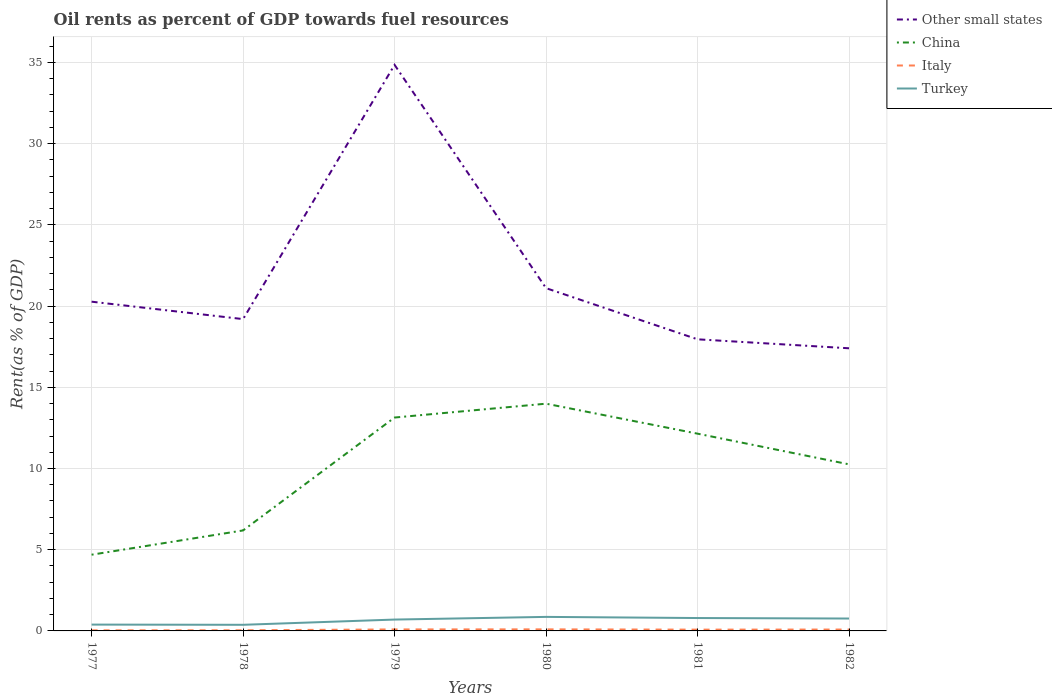Does the line corresponding to Other small states intersect with the line corresponding to Italy?
Offer a terse response. No. Is the number of lines equal to the number of legend labels?
Your answer should be very brief. Yes. Across all years, what is the maximum oil rent in Other small states?
Your response must be concise. 17.4. In which year was the oil rent in Italy maximum?
Your answer should be compact. 1977. What is the total oil rent in Other small states in the graph?
Provide a short and direct response. 3.7. What is the difference between the highest and the second highest oil rent in Other small states?
Your response must be concise. 17.45. What is the difference between the highest and the lowest oil rent in China?
Offer a very short reply. 4. Are the values on the major ticks of Y-axis written in scientific E-notation?
Offer a very short reply. No. Does the graph contain grids?
Ensure brevity in your answer.  Yes. How are the legend labels stacked?
Offer a terse response. Vertical. What is the title of the graph?
Make the answer very short. Oil rents as percent of GDP towards fuel resources. What is the label or title of the Y-axis?
Make the answer very short. Rent(as % of GDP). What is the Rent(as % of GDP) in Other small states in 1977?
Offer a very short reply. 20.27. What is the Rent(as % of GDP) in China in 1977?
Your answer should be compact. 4.69. What is the Rent(as % of GDP) of Italy in 1977?
Your response must be concise. 0.04. What is the Rent(as % of GDP) of Turkey in 1977?
Provide a succinct answer. 0.39. What is the Rent(as % of GDP) of Other small states in 1978?
Your answer should be very brief. 19.2. What is the Rent(as % of GDP) of China in 1978?
Keep it short and to the point. 6.19. What is the Rent(as % of GDP) of Italy in 1978?
Ensure brevity in your answer.  0.04. What is the Rent(as % of GDP) in Turkey in 1978?
Provide a short and direct response. 0.38. What is the Rent(as % of GDP) in Other small states in 1979?
Offer a very short reply. 34.86. What is the Rent(as % of GDP) in China in 1979?
Give a very brief answer. 13.14. What is the Rent(as % of GDP) in Italy in 1979?
Offer a very short reply. 0.09. What is the Rent(as % of GDP) of Turkey in 1979?
Provide a short and direct response. 0.7. What is the Rent(as % of GDP) of Other small states in 1980?
Offer a terse response. 21.1. What is the Rent(as % of GDP) in China in 1980?
Give a very brief answer. 13.99. What is the Rent(as % of GDP) of Italy in 1980?
Your answer should be compact. 0.1. What is the Rent(as % of GDP) of Turkey in 1980?
Offer a very short reply. 0.86. What is the Rent(as % of GDP) in Other small states in 1981?
Your response must be concise. 17.96. What is the Rent(as % of GDP) in China in 1981?
Offer a very short reply. 12.15. What is the Rent(as % of GDP) of Italy in 1981?
Offer a very short reply. 0.08. What is the Rent(as % of GDP) of Turkey in 1981?
Offer a terse response. 0.79. What is the Rent(as % of GDP) in Other small states in 1982?
Ensure brevity in your answer.  17.4. What is the Rent(as % of GDP) of China in 1982?
Offer a very short reply. 10.26. What is the Rent(as % of GDP) of Italy in 1982?
Provide a succinct answer. 0.09. What is the Rent(as % of GDP) in Turkey in 1982?
Offer a terse response. 0.76. Across all years, what is the maximum Rent(as % of GDP) of Other small states?
Ensure brevity in your answer.  34.86. Across all years, what is the maximum Rent(as % of GDP) in China?
Your answer should be very brief. 13.99. Across all years, what is the maximum Rent(as % of GDP) in Italy?
Give a very brief answer. 0.1. Across all years, what is the maximum Rent(as % of GDP) in Turkey?
Provide a short and direct response. 0.86. Across all years, what is the minimum Rent(as % of GDP) of Other small states?
Provide a short and direct response. 17.4. Across all years, what is the minimum Rent(as % of GDP) in China?
Your answer should be very brief. 4.69. Across all years, what is the minimum Rent(as % of GDP) in Italy?
Your response must be concise. 0.04. Across all years, what is the minimum Rent(as % of GDP) of Turkey?
Offer a very short reply. 0.38. What is the total Rent(as % of GDP) in Other small states in the graph?
Offer a terse response. 130.79. What is the total Rent(as % of GDP) in China in the graph?
Make the answer very short. 60.41. What is the total Rent(as % of GDP) of Italy in the graph?
Your response must be concise. 0.43. What is the total Rent(as % of GDP) of Turkey in the graph?
Your response must be concise. 3.89. What is the difference between the Rent(as % of GDP) in Other small states in 1977 and that in 1978?
Provide a succinct answer. 1.07. What is the difference between the Rent(as % of GDP) in China in 1977 and that in 1978?
Offer a terse response. -1.49. What is the difference between the Rent(as % of GDP) of Italy in 1977 and that in 1978?
Your answer should be very brief. -0. What is the difference between the Rent(as % of GDP) in Turkey in 1977 and that in 1978?
Provide a succinct answer. 0.01. What is the difference between the Rent(as % of GDP) of Other small states in 1977 and that in 1979?
Give a very brief answer. -14.58. What is the difference between the Rent(as % of GDP) in China in 1977 and that in 1979?
Your answer should be very brief. -8.45. What is the difference between the Rent(as % of GDP) of Italy in 1977 and that in 1979?
Give a very brief answer. -0.06. What is the difference between the Rent(as % of GDP) of Turkey in 1977 and that in 1979?
Ensure brevity in your answer.  -0.31. What is the difference between the Rent(as % of GDP) in Other small states in 1977 and that in 1980?
Offer a very short reply. -0.83. What is the difference between the Rent(as % of GDP) of China in 1977 and that in 1980?
Provide a short and direct response. -9.3. What is the difference between the Rent(as % of GDP) in Italy in 1977 and that in 1980?
Provide a short and direct response. -0.06. What is the difference between the Rent(as % of GDP) of Turkey in 1977 and that in 1980?
Give a very brief answer. -0.47. What is the difference between the Rent(as % of GDP) of Other small states in 1977 and that in 1981?
Ensure brevity in your answer.  2.32. What is the difference between the Rent(as % of GDP) of China in 1977 and that in 1981?
Provide a short and direct response. -7.45. What is the difference between the Rent(as % of GDP) in Italy in 1977 and that in 1981?
Ensure brevity in your answer.  -0.04. What is the difference between the Rent(as % of GDP) in Turkey in 1977 and that in 1981?
Provide a succinct answer. -0.4. What is the difference between the Rent(as % of GDP) in Other small states in 1977 and that in 1982?
Offer a terse response. 2.87. What is the difference between the Rent(as % of GDP) in China in 1977 and that in 1982?
Give a very brief answer. -5.56. What is the difference between the Rent(as % of GDP) of Italy in 1977 and that in 1982?
Your response must be concise. -0.05. What is the difference between the Rent(as % of GDP) of Turkey in 1977 and that in 1982?
Make the answer very short. -0.37. What is the difference between the Rent(as % of GDP) in Other small states in 1978 and that in 1979?
Make the answer very short. -15.66. What is the difference between the Rent(as % of GDP) of China in 1978 and that in 1979?
Make the answer very short. -6.95. What is the difference between the Rent(as % of GDP) of Italy in 1978 and that in 1979?
Give a very brief answer. -0.05. What is the difference between the Rent(as % of GDP) of Turkey in 1978 and that in 1979?
Provide a succinct answer. -0.32. What is the difference between the Rent(as % of GDP) in Other small states in 1978 and that in 1980?
Offer a terse response. -1.91. What is the difference between the Rent(as % of GDP) in China in 1978 and that in 1980?
Ensure brevity in your answer.  -7.8. What is the difference between the Rent(as % of GDP) of Italy in 1978 and that in 1980?
Offer a terse response. -0.06. What is the difference between the Rent(as % of GDP) in Turkey in 1978 and that in 1980?
Your response must be concise. -0.49. What is the difference between the Rent(as % of GDP) in Other small states in 1978 and that in 1981?
Your response must be concise. 1.24. What is the difference between the Rent(as % of GDP) of China in 1978 and that in 1981?
Offer a very short reply. -5.96. What is the difference between the Rent(as % of GDP) of Italy in 1978 and that in 1981?
Provide a short and direct response. -0.04. What is the difference between the Rent(as % of GDP) of Turkey in 1978 and that in 1981?
Offer a very short reply. -0.42. What is the difference between the Rent(as % of GDP) in Other small states in 1978 and that in 1982?
Offer a terse response. 1.8. What is the difference between the Rent(as % of GDP) of China in 1978 and that in 1982?
Offer a very short reply. -4.07. What is the difference between the Rent(as % of GDP) in Italy in 1978 and that in 1982?
Your answer should be very brief. -0.04. What is the difference between the Rent(as % of GDP) in Turkey in 1978 and that in 1982?
Give a very brief answer. -0.39. What is the difference between the Rent(as % of GDP) of Other small states in 1979 and that in 1980?
Keep it short and to the point. 13.75. What is the difference between the Rent(as % of GDP) in China in 1979 and that in 1980?
Your answer should be very brief. -0.85. What is the difference between the Rent(as % of GDP) in Italy in 1979 and that in 1980?
Keep it short and to the point. -0. What is the difference between the Rent(as % of GDP) of Turkey in 1979 and that in 1980?
Provide a short and direct response. -0.16. What is the difference between the Rent(as % of GDP) in Other small states in 1979 and that in 1981?
Provide a succinct answer. 16.9. What is the difference between the Rent(as % of GDP) of Italy in 1979 and that in 1981?
Offer a very short reply. 0.01. What is the difference between the Rent(as % of GDP) in Turkey in 1979 and that in 1981?
Keep it short and to the point. -0.09. What is the difference between the Rent(as % of GDP) in Other small states in 1979 and that in 1982?
Keep it short and to the point. 17.45. What is the difference between the Rent(as % of GDP) of China in 1979 and that in 1982?
Give a very brief answer. 2.88. What is the difference between the Rent(as % of GDP) of Italy in 1979 and that in 1982?
Your answer should be very brief. 0.01. What is the difference between the Rent(as % of GDP) of Turkey in 1979 and that in 1982?
Ensure brevity in your answer.  -0.06. What is the difference between the Rent(as % of GDP) of Other small states in 1980 and that in 1981?
Provide a succinct answer. 3.15. What is the difference between the Rent(as % of GDP) of China in 1980 and that in 1981?
Ensure brevity in your answer.  1.85. What is the difference between the Rent(as % of GDP) of Italy in 1980 and that in 1981?
Ensure brevity in your answer.  0.02. What is the difference between the Rent(as % of GDP) of Turkey in 1980 and that in 1981?
Your answer should be very brief. 0.07. What is the difference between the Rent(as % of GDP) in Other small states in 1980 and that in 1982?
Keep it short and to the point. 3.7. What is the difference between the Rent(as % of GDP) of China in 1980 and that in 1982?
Make the answer very short. 3.73. What is the difference between the Rent(as % of GDP) of Italy in 1980 and that in 1982?
Make the answer very short. 0.01. What is the difference between the Rent(as % of GDP) of Turkey in 1980 and that in 1982?
Make the answer very short. 0.1. What is the difference between the Rent(as % of GDP) in Other small states in 1981 and that in 1982?
Your answer should be very brief. 0.55. What is the difference between the Rent(as % of GDP) of China in 1981 and that in 1982?
Keep it short and to the point. 1.89. What is the difference between the Rent(as % of GDP) of Italy in 1981 and that in 1982?
Give a very brief answer. -0.01. What is the difference between the Rent(as % of GDP) in Turkey in 1981 and that in 1982?
Your response must be concise. 0.03. What is the difference between the Rent(as % of GDP) in Other small states in 1977 and the Rent(as % of GDP) in China in 1978?
Ensure brevity in your answer.  14.09. What is the difference between the Rent(as % of GDP) of Other small states in 1977 and the Rent(as % of GDP) of Italy in 1978?
Ensure brevity in your answer.  20.23. What is the difference between the Rent(as % of GDP) of Other small states in 1977 and the Rent(as % of GDP) of Turkey in 1978?
Make the answer very short. 19.9. What is the difference between the Rent(as % of GDP) of China in 1977 and the Rent(as % of GDP) of Italy in 1978?
Your answer should be very brief. 4.65. What is the difference between the Rent(as % of GDP) of China in 1977 and the Rent(as % of GDP) of Turkey in 1978?
Your answer should be very brief. 4.32. What is the difference between the Rent(as % of GDP) of Italy in 1977 and the Rent(as % of GDP) of Turkey in 1978?
Keep it short and to the point. -0.34. What is the difference between the Rent(as % of GDP) in Other small states in 1977 and the Rent(as % of GDP) in China in 1979?
Your answer should be compact. 7.13. What is the difference between the Rent(as % of GDP) in Other small states in 1977 and the Rent(as % of GDP) in Italy in 1979?
Offer a terse response. 20.18. What is the difference between the Rent(as % of GDP) in Other small states in 1977 and the Rent(as % of GDP) in Turkey in 1979?
Provide a succinct answer. 19.57. What is the difference between the Rent(as % of GDP) of China in 1977 and the Rent(as % of GDP) of Italy in 1979?
Keep it short and to the point. 4.6. What is the difference between the Rent(as % of GDP) in China in 1977 and the Rent(as % of GDP) in Turkey in 1979?
Keep it short and to the point. 3.99. What is the difference between the Rent(as % of GDP) in Italy in 1977 and the Rent(as % of GDP) in Turkey in 1979?
Provide a succinct answer. -0.66. What is the difference between the Rent(as % of GDP) of Other small states in 1977 and the Rent(as % of GDP) of China in 1980?
Give a very brief answer. 6.28. What is the difference between the Rent(as % of GDP) in Other small states in 1977 and the Rent(as % of GDP) in Italy in 1980?
Provide a succinct answer. 20.18. What is the difference between the Rent(as % of GDP) of Other small states in 1977 and the Rent(as % of GDP) of Turkey in 1980?
Your answer should be compact. 19.41. What is the difference between the Rent(as % of GDP) in China in 1977 and the Rent(as % of GDP) in Italy in 1980?
Give a very brief answer. 4.6. What is the difference between the Rent(as % of GDP) of China in 1977 and the Rent(as % of GDP) of Turkey in 1980?
Provide a succinct answer. 3.83. What is the difference between the Rent(as % of GDP) of Italy in 1977 and the Rent(as % of GDP) of Turkey in 1980?
Provide a short and direct response. -0.83. What is the difference between the Rent(as % of GDP) of Other small states in 1977 and the Rent(as % of GDP) of China in 1981?
Your response must be concise. 8.13. What is the difference between the Rent(as % of GDP) of Other small states in 1977 and the Rent(as % of GDP) of Italy in 1981?
Your response must be concise. 20.19. What is the difference between the Rent(as % of GDP) in Other small states in 1977 and the Rent(as % of GDP) in Turkey in 1981?
Provide a succinct answer. 19.48. What is the difference between the Rent(as % of GDP) of China in 1977 and the Rent(as % of GDP) of Italy in 1981?
Provide a short and direct response. 4.61. What is the difference between the Rent(as % of GDP) in China in 1977 and the Rent(as % of GDP) in Turkey in 1981?
Keep it short and to the point. 3.9. What is the difference between the Rent(as % of GDP) in Italy in 1977 and the Rent(as % of GDP) in Turkey in 1981?
Give a very brief answer. -0.76. What is the difference between the Rent(as % of GDP) of Other small states in 1977 and the Rent(as % of GDP) of China in 1982?
Offer a very short reply. 10.02. What is the difference between the Rent(as % of GDP) in Other small states in 1977 and the Rent(as % of GDP) in Italy in 1982?
Provide a short and direct response. 20.19. What is the difference between the Rent(as % of GDP) in Other small states in 1977 and the Rent(as % of GDP) in Turkey in 1982?
Your answer should be compact. 19.51. What is the difference between the Rent(as % of GDP) of China in 1977 and the Rent(as % of GDP) of Italy in 1982?
Your response must be concise. 4.61. What is the difference between the Rent(as % of GDP) of China in 1977 and the Rent(as % of GDP) of Turkey in 1982?
Provide a succinct answer. 3.93. What is the difference between the Rent(as % of GDP) of Italy in 1977 and the Rent(as % of GDP) of Turkey in 1982?
Your response must be concise. -0.73. What is the difference between the Rent(as % of GDP) in Other small states in 1978 and the Rent(as % of GDP) in China in 1979?
Your answer should be compact. 6.06. What is the difference between the Rent(as % of GDP) of Other small states in 1978 and the Rent(as % of GDP) of Italy in 1979?
Ensure brevity in your answer.  19.11. What is the difference between the Rent(as % of GDP) in Other small states in 1978 and the Rent(as % of GDP) in Turkey in 1979?
Keep it short and to the point. 18.5. What is the difference between the Rent(as % of GDP) in China in 1978 and the Rent(as % of GDP) in Italy in 1979?
Offer a terse response. 6.09. What is the difference between the Rent(as % of GDP) of China in 1978 and the Rent(as % of GDP) of Turkey in 1979?
Provide a succinct answer. 5.49. What is the difference between the Rent(as % of GDP) in Italy in 1978 and the Rent(as % of GDP) in Turkey in 1979?
Offer a terse response. -0.66. What is the difference between the Rent(as % of GDP) in Other small states in 1978 and the Rent(as % of GDP) in China in 1980?
Provide a short and direct response. 5.21. What is the difference between the Rent(as % of GDP) of Other small states in 1978 and the Rent(as % of GDP) of Italy in 1980?
Give a very brief answer. 19.1. What is the difference between the Rent(as % of GDP) of Other small states in 1978 and the Rent(as % of GDP) of Turkey in 1980?
Offer a very short reply. 18.34. What is the difference between the Rent(as % of GDP) of China in 1978 and the Rent(as % of GDP) of Italy in 1980?
Ensure brevity in your answer.  6.09. What is the difference between the Rent(as % of GDP) of China in 1978 and the Rent(as % of GDP) of Turkey in 1980?
Your answer should be very brief. 5.32. What is the difference between the Rent(as % of GDP) in Italy in 1978 and the Rent(as % of GDP) in Turkey in 1980?
Offer a terse response. -0.82. What is the difference between the Rent(as % of GDP) in Other small states in 1978 and the Rent(as % of GDP) in China in 1981?
Give a very brief answer. 7.05. What is the difference between the Rent(as % of GDP) of Other small states in 1978 and the Rent(as % of GDP) of Italy in 1981?
Ensure brevity in your answer.  19.12. What is the difference between the Rent(as % of GDP) of Other small states in 1978 and the Rent(as % of GDP) of Turkey in 1981?
Offer a very short reply. 18.41. What is the difference between the Rent(as % of GDP) of China in 1978 and the Rent(as % of GDP) of Italy in 1981?
Your response must be concise. 6.11. What is the difference between the Rent(as % of GDP) in China in 1978 and the Rent(as % of GDP) in Turkey in 1981?
Ensure brevity in your answer.  5.39. What is the difference between the Rent(as % of GDP) of Italy in 1978 and the Rent(as % of GDP) of Turkey in 1981?
Provide a succinct answer. -0.75. What is the difference between the Rent(as % of GDP) in Other small states in 1978 and the Rent(as % of GDP) in China in 1982?
Your answer should be very brief. 8.94. What is the difference between the Rent(as % of GDP) in Other small states in 1978 and the Rent(as % of GDP) in Italy in 1982?
Your response must be concise. 19.11. What is the difference between the Rent(as % of GDP) in Other small states in 1978 and the Rent(as % of GDP) in Turkey in 1982?
Your answer should be very brief. 18.44. What is the difference between the Rent(as % of GDP) of China in 1978 and the Rent(as % of GDP) of Italy in 1982?
Provide a succinct answer. 6.1. What is the difference between the Rent(as % of GDP) in China in 1978 and the Rent(as % of GDP) in Turkey in 1982?
Give a very brief answer. 5.42. What is the difference between the Rent(as % of GDP) in Italy in 1978 and the Rent(as % of GDP) in Turkey in 1982?
Make the answer very short. -0.72. What is the difference between the Rent(as % of GDP) in Other small states in 1979 and the Rent(as % of GDP) in China in 1980?
Offer a terse response. 20.86. What is the difference between the Rent(as % of GDP) in Other small states in 1979 and the Rent(as % of GDP) in Italy in 1980?
Keep it short and to the point. 34.76. What is the difference between the Rent(as % of GDP) of Other small states in 1979 and the Rent(as % of GDP) of Turkey in 1980?
Your response must be concise. 33.99. What is the difference between the Rent(as % of GDP) in China in 1979 and the Rent(as % of GDP) in Italy in 1980?
Offer a terse response. 13.04. What is the difference between the Rent(as % of GDP) of China in 1979 and the Rent(as % of GDP) of Turkey in 1980?
Your answer should be compact. 12.27. What is the difference between the Rent(as % of GDP) of Italy in 1979 and the Rent(as % of GDP) of Turkey in 1980?
Give a very brief answer. -0.77. What is the difference between the Rent(as % of GDP) of Other small states in 1979 and the Rent(as % of GDP) of China in 1981?
Your answer should be compact. 22.71. What is the difference between the Rent(as % of GDP) in Other small states in 1979 and the Rent(as % of GDP) in Italy in 1981?
Offer a very short reply. 34.78. What is the difference between the Rent(as % of GDP) in Other small states in 1979 and the Rent(as % of GDP) in Turkey in 1981?
Provide a short and direct response. 34.06. What is the difference between the Rent(as % of GDP) in China in 1979 and the Rent(as % of GDP) in Italy in 1981?
Your answer should be compact. 13.06. What is the difference between the Rent(as % of GDP) in China in 1979 and the Rent(as % of GDP) in Turkey in 1981?
Provide a succinct answer. 12.34. What is the difference between the Rent(as % of GDP) of Italy in 1979 and the Rent(as % of GDP) of Turkey in 1981?
Provide a short and direct response. -0.7. What is the difference between the Rent(as % of GDP) of Other small states in 1979 and the Rent(as % of GDP) of China in 1982?
Your answer should be very brief. 24.6. What is the difference between the Rent(as % of GDP) in Other small states in 1979 and the Rent(as % of GDP) in Italy in 1982?
Offer a terse response. 34.77. What is the difference between the Rent(as % of GDP) in Other small states in 1979 and the Rent(as % of GDP) in Turkey in 1982?
Your answer should be compact. 34.09. What is the difference between the Rent(as % of GDP) of China in 1979 and the Rent(as % of GDP) of Italy in 1982?
Give a very brief answer. 13.05. What is the difference between the Rent(as % of GDP) of China in 1979 and the Rent(as % of GDP) of Turkey in 1982?
Your response must be concise. 12.38. What is the difference between the Rent(as % of GDP) in Italy in 1979 and the Rent(as % of GDP) in Turkey in 1982?
Provide a short and direct response. -0.67. What is the difference between the Rent(as % of GDP) in Other small states in 1980 and the Rent(as % of GDP) in China in 1981?
Provide a succinct answer. 8.96. What is the difference between the Rent(as % of GDP) of Other small states in 1980 and the Rent(as % of GDP) of Italy in 1981?
Provide a succinct answer. 21.03. What is the difference between the Rent(as % of GDP) in Other small states in 1980 and the Rent(as % of GDP) in Turkey in 1981?
Provide a succinct answer. 20.31. What is the difference between the Rent(as % of GDP) of China in 1980 and the Rent(as % of GDP) of Italy in 1981?
Your response must be concise. 13.91. What is the difference between the Rent(as % of GDP) of China in 1980 and the Rent(as % of GDP) of Turkey in 1981?
Ensure brevity in your answer.  13.2. What is the difference between the Rent(as % of GDP) of Italy in 1980 and the Rent(as % of GDP) of Turkey in 1981?
Your response must be concise. -0.7. What is the difference between the Rent(as % of GDP) of Other small states in 1980 and the Rent(as % of GDP) of China in 1982?
Give a very brief answer. 10.85. What is the difference between the Rent(as % of GDP) in Other small states in 1980 and the Rent(as % of GDP) in Italy in 1982?
Your answer should be very brief. 21.02. What is the difference between the Rent(as % of GDP) of Other small states in 1980 and the Rent(as % of GDP) of Turkey in 1982?
Your answer should be very brief. 20.34. What is the difference between the Rent(as % of GDP) of China in 1980 and the Rent(as % of GDP) of Italy in 1982?
Ensure brevity in your answer.  13.91. What is the difference between the Rent(as % of GDP) in China in 1980 and the Rent(as % of GDP) in Turkey in 1982?
Keep it short and to the point. 13.23. What is the difference between the Rent(as % of GDP) of Italy in 1980 and the Rent(as % of GDP) of Turkey in 1982?
Provide a succinct answer. -0.67. What is the difference between the Rent(as % of GDP) in Other small states in 1981 and the Rent(as % of GDP) in China in 1982?
Provide a short and direct response. 7.7. What is the difference between the Rent(as % of GDP) of Other small states in 1981 and the Rent(as % of GDP) of Italy in 1982?
Ensure brevity in your answer.  17.87. What is the difference between the Rent(as % of GDP) of Other small states in 1981 and the Rent(as % of GDP) of Turkey in 1982?
Keep it short and to the point. 17.19. What is the difference between the Rent(as % of GDP) of China in 1981 and the Rent(as % of GDP) of Italy in 1982?
Give a very brief answer. 12.06. What is the difference between the Rent(as % of GDP) of China in 1981 and the Rent(as % of GDP) of Turkey in 1982?
Give a very brief answer. 11.38. What is the difference between the Rent(as % of GDP) in Italy in 1981 and the Rent(as % of GDP) in Turkey in 1982?
Give a very brief answer. -0.68. What is the average Rent(as % of GDP) in Other small states per year?
Provide a succinct answer. 21.8. What is the average Rent(as % of GDP) in China per year?
Your response must be concise. 10.07. What is the average Rent(as % of GDP) in Italy per year?
Offer a terse response. 0.07. What is the average Rent(as % of GDP) of Turkey per year?
Your answer should be very brief. 0.65. In the year 1977, what is the difference between the Rent(as % of GDP) in Other small states and Rent(as % of GDP) in China?
Your answer should be very brief. 15.58. In the year 1977, what is the difference between the Rent(as % of GDP) in Other small states and Rent(as % of GDP) in Italy?
Give a very brief answer. 20.24. In the year 1977, what is the difference between the Rent(as % of GDP) in Other small states and Rent(as % of GDP) in Turkey?
Give a very brief answer. 19.88. In the year 1977, what is the difference between the Rent(as % of GDP) of China and Rent(as % of GDP) of Italy?
Ensure brevity in your answer.  4.66. In the year 1977, what is the difference between the Rent(as % of GDP) in China and Rent(as % of GDP) in Turkey?
Offer a very short reply. 4.3. In the year 1977, what is the difference between the Rent(as % of GDP) in Italy and Rent(as % of GDP) in Turkey?
Your answer should be very brief. -0.35. In the year 1978, what is the difference between the Rent(as % of GDP) in Other small states and Rent(as % of GDP) in China?
Keep it short and to the point. 13.01. In the year 1978, what is the difference between the Rent(as % of GDP) of Other small states and Rent(as % of GDP) of Italy?
Offer a very short reply. 19.16. In the year 1978, what is the difference between the Rent(as % of GDP) of Other small states and Rent(as % of GDP) of Turkey?
Your answer should be compact. 18.82. In the year 1978, what is the difference between the Rent(as % of GDP) of China and Rent(as % of GDP) of Italy?
Offer a very short reply. 6.15. In the year 1978, what is the difference between the Rent(as % of GDP) in China and Rent(as % of GDP) in Turkey?
Give a very brief answer. 5.81. In the year 1978, what is the difference between the Rent(as % of GDP) in Italy and Rent(as % of GDP) in Turkey?
Offer a very short reply. -0.34. In the year 1979, what is the difference between the Rent(as % of GDP) in Other small states and Rent(as % of GDP) in China?
Offer a very short reply. 21.72. In the year 1979, what is the difference between the Rent(as % of GDP) of Other small states and Rent(as % of GDP) of Italy?
Your response must be concise. 34.76. In the year 1979, what is the difference between the Rent(as % of GDP) in Other small states and Rent(as % of GDP) in Turkey?
Offer a very short reply. 34.16. In the year 1979, what is the difference between the Rent(as % of GDP) in China and Rent(as % of GDP) in Italy?
Give a very brief answer. 13.05. In the year 1979, what is the difference between the Rent(as % of GDP) in China and Rent(as % of GDP) in Turkey?
Offer a terse response. 12.44. In the year 1979, what is the difference between the Rent(as % of GDP) in Italy and Rent(as % of GDP) in Turkey?
Your answer should be very brief. -0.61. In the year 1980, what is the difference between the Rent(as % of GDP) of Other small states and Rent(as % of GDP) of China?
Provide a succinct answer. 7.11. In the year 1980, what is the difference between the Rent(as % of GDP) in Other small states and Rent(as % of GDP) in Italy?
Your answer should be compact. 21.01. In the year 1980, what is the difference between the Rent(as % of GDP) of Other small states and Rent(as % of GDP) of Turkey?
Give a very brief answer. 20.24. In the year 1980, what is the difference between the Rent(as % of GDP) in China and Rent(as % of GDP) in Italy?
Your answer should be very brief. 13.9. In the year 1980, what is the difference between the Rent(as % of GDP) in China and Rent(as % of GDP) in Turkey?
Ensure brevity in your answer.  13.13. In the year 1980, what is the difference between the Rent(as % of GDP) of Italy and Rent(as % of GDP) of Turkey?
Give a very brief answer. -0.77. In the year 1981, what is the difference between the Rent(as % of GDP) of Other small states and Rent(as % of GDP) of China?
Provide a short and direct response. 5.81. In the year 1981, what is the difference between the Rent(as % of GDP) of Other small states and Rent(as % of GDP) of Italy?
Give a very brief answer. 17.88. In the year 1981, what is the difference between the Rent(as % of GDP) in Other small states and Rent(as % of GDP) in Turkey?
Ensure brevity in your answer.  17.16. In the year 1981, what is the difference between the Rent(as % of GDP) in China and Rent(as % of GDP) in Italy?
Provide a succinct answer. 12.07. In the year 1981, what is the difference between the Rent(as % of GDP) in China and Rent(as % of GDP) in Turkey?
Your answer should be compact. 11.35. In the year 1981, what is the difference between the Rent(as % of GDP) of Italy and Rent(as % of GDP) of Turkey?
Offer a terse response. -0.71. In the year 1982, what is the difference between the Rent(as % of GDP) of Other small states and Rent(as % of GDP) of China?
Make the answer very short. 7.15. In the year 1982, what is the difference between the Rent(as % of GDP) in Other small states and Rent(as % of GDP) in Italy?
Keep it short and to the point. 17.32. In the year 1982, what is the difference between the Rent(as % of GDP) in Other small states and Rent(as % of GDP) in Turkey?
Offer a terse response. 16.64. In the year 1982, what is the difference between the Rent(as % of GDP) in China and Rent(as % of GDP) in Italy?
Give a very brief answer. 10.17. In the year 1982, what is the difference between the Rent(as % of GDP) in China and Rent(as % of GDP) in Turkey?
Your answer should be very brief. 9.49. In the year 1982, what is the difference between the Rent(as % of GDP) in Italy and Rent(as % of GDP) in Turkey?
Offer a very short reply. -0.68. What is the ratio of the Rent(as % of GDP) in Other small states in 1977 to that in 1978?
Give a very brief answer. 1.06. What is the ratio of the Rent(as % of GDP) in China in 1977 to that in 1978?
Give a very brief answer. 0.76. What is the ratio of the Rent(as % of GDP) of Italy in 1977 to that in 1978?
Make the answer very short. 0.91. What is the ratio of the Rent(as % of GDP) in Turkey in 1977 to that in 1978?
Provide a succinct answer. 1.03. What is the ratio of the Rent(as % of GDP) in Other small states in 1977 to that in 1979?
Your response must be concise. 0.58. What is the ratio of the Rent(as % of GDP) of China in 1977 to that in 1979?
Give a very brief answer. 0.36. What is the ratio of the Rent(as % of GDP) of Italy in 1977 to that in 1979?
Keep it short and to the point. 0.4. What is the ratio of the Rent(as % of GDP) in Turkey in 1977 to that in 1979?
Make the answer very short. 0.56. What is the ratio of the Rent(as % of GDP) in Other small states in 1977 to that in 1980?
Ensure brevity in your answer.  0.96. What is the ratio of the Rent(as % of GDP) of China in 1977 to that in 1980?
Give a very brief answer. 0.34. What is the ratio of the Rent(as % of GDP) of Italy in 1977 to that in 1980?
Offer a very short reply. 0.38. What is the ratio of the Rent(as % of GDP) in Turkey in 1977 to that in 1980?
Offer a terse response. 0.45. What is the ratio of the Rent(as % of GDP) of Other small states in 1977 to that in 1981?
Your answer should be compact. 1.13. What is the ratio of the Rent(as % of GDP) of China in 1977 to that in 1981?
Ensure brevity in your answer.  0.39. What is the ratio of the Rent(as % of GDP) of Italy in 1977 to that in 1981?
Keep it short and to the point. 0.46. What is the ratio of the Rent(as % of GDP) of Turkey in 1977 to that in 1981?
Your answer should be compact. 0.49. What is the ratio of the Rent(as % of GDP) of Other small states in 1977 to that in 1982?
Give a very brief answer. 1.16. What is the ratio of the Rent(as % of GDP) of China in 1977 to that in 1982?
Provide a short and direct response. 0.46. What is the ratio of the Rent(as % of GDP) of Italy in 1977 to that in 1982?
Your answer should be very brief. 0.43. What is the ratio of the Rent(as % of GDP) in Turkey in 1977 to that in 1982?
Offer a terse response. 0.51. What is the ratio of the Rent(as % of GDP) in Other small states in 1978 to that in 1979?
Provide a short and direct response. 0.55. What is the ratio of the Rent(as % of GDP) of China in 1978 to that in 1979?
Offer a terse response. 0.47. What is the ratio of the Rent(as % of GDP) in Italy in 1978 to that in 1979?
Offer a terse response. 0.44. What is the ratio of the Rent(as % of GDP) of Turkey in 1978 to that in 1979?
Your answer should be compact. 0.54. What is the ratio of the Rent(as % of GDP) of Other small states in 1978 to that in 1980?
Provide a succinct answer. 0.91. What is the ratio of the Rent(as % of GDP) in China in 1978 to that in 1980?
Your answer should be very brief. 0.44. What is the ratio of the Rent(as % of GDP) of Italy in 1978 to that in 1980?
Keep it short and to the point. 0.42. What is the ratio of the Rent(as % of GDP) in Turkey in 1978 to that in 1980?
Make the answer very short. 0.44. What is the ratio of the Rent(as % of GDP) of Other small states in 1978 to that in 1981?
Your answer should be compact. 1.07. What is the ratio of the Rent(as % of GDP) in China in 1978 to that in 1981?
Give a very brief answer. 0.51. What is the ratio of the Rent(as % of GDP) in Italy in 1978 to that in 1981?
Keep it short and to the point. 0.51. What is the ratio of the Rent(as % of GDP) in Turkey in 1978 to that in 1981?
Offer a terse response. 0.47. What is the ratio of the Rent(as % of GDP) in Other small states in 1978 to that in 1982?
Provide a succinct answer. 1.1. What is the ratio of the Rent(as % of GDP) in China in 1978 to that in 1982?
Your answer should be compact. 0.6. What is the ratio of the Rent(as % of GDP) in Italy in 1978 to that in 1982?
Provide a succinct answer. 0.48. What is the ratio of the Rent(as % of GDP) of Turkey in 1978 to that in 1982?
Keep it short and to the point. 0.49. What is the ratio of the Rent(as % of GDP) in Other small states in 1979 to that in 1980?
Make the answer very short. 1.65. What is the ratio of the Rent(as % of GDP) of China in 1979 to that in 1980?
Provide a short and direct response. 0.94. What is the ratio of the Rent(as % of GDP) in Italy in 1979 to that in 1980?
Your answer should be compact. 0.96. What is the ratio of the Rent(as % of GDP) in Turkey in 1979 to that in 1980?
Offer a very short reply. 0.81. What is the ratio of the Rent(as % of GDP) of Other small states in 1979 to that in 1981?
Your answer should be compact. 1.94. What is the ratio of the Rent(as % of GDP) of China in 1979 to that in 1981?
Your answer should be compact. 1.08. What is the ratio of the Rent(as % of GDP) of Italy in 1979 to that in 1981?
Make the answer very short. 1.16. What is the ratio of the Rent(as % of GDP) of Turkey in 1979 to that in 1981?
Your response must be concise. 0.88. What is the ratio of the Rent(as % of GDP) of Other small states in 1979 to that in 1982?
Offer a very short reply. 2. What is the ratio of the Rent(as % of GDP) in China in 1979 to that in 1982?
Offer a terse response. 1.28. What is the ratio of the Rent(as % of GDP) in Italy in 1979 to that in 1982?
Your answer should be compact. 1.08. What is the ratio of the Rent(as % of GDP) in Turkey in 1979 to that in 1982?
Your response must be concise. 0.92. What is the ratio of the Rent(as % of GDP) of Other small states in 1980 to that in 1981?
Keep it short and to the point. 1.18. What is the ratio of the Rent(as % of GDP) in China in 1980 to that in 1981?
Ensure brevity in your answer.  1.15. What is the ratio of the Rent(as % of GDP) of Italy in 1980 to that in 1981?
Offer a terse response. 1.21. What is the ratio of the Rent(as % of GDP) of Turkey in 1980 to that in 1981?
Ensure brevity in your answer.  1.09. What is the ratio of the Rent(as % of GDP) in Other small states in 1980 to that in 1982?
Keep it short and to the point. 1.21. What is the ratio of the Rent(as % of GDP) of China in 1980 to that in 1982?
Give a very brief answer. 1.36. What is the ratio of the Rent(as % of GDP) of Italy in 1980 to that in 1982?
Provide a succinct answer. 1.13. What is the ratio of the Rent(as % of GDP) of Turkey in 1980 to that in 1982?
Your answer should be compact. 1.13. What is the ratio of the Rent(as % of GDP) of Other small states in 1981 to that in 1982?
Offer a very short reply. 1.03. What is the ratio of the Rent(as % of GDP) of China in 1981 to that in 1982?
Your answer should be compact. 1.18. What is the ratio of the Rent(as % of GDP) in Italy in 1981 to that in 1982?
Give a very brief answer. 0.93. What is the ratio of the Rent(as % of GDP) in Turkey in 1981 to that in 1982?
Your response must be concise. 1.04. What is the difference between the highest and the second highest Rent(as % of GDP) in Other small states?
Keep it short and to the point. 13.75. What is the difference between the highest and the second highest Rent(as % of GDP) of China?
Provide a short and direct response. 0.85. What is the difference between the highest and the second highest Rent(as % of GDP) in Italy?
Your response must be concise. 0. What is the difference between the highest and the second highest Rent(as % of GDP) in Turkey?
Ensure brevity in your answer.  0.07. What is the difference between the highest and the lowest Rent(as % of GDP) in Other small states?
Offer a terse response. 17.45. What is the difference between the highest and the lowest Rent(as % of GDP) in China?
Keep it short and to the point. 9.3. What is the difference between the highest and the lowest Rent(as % of GDP) in Italy?
Make the answer very short. 0.06. What is the difference between the highest and the lowest Rent(as % of GDP) of Turkey?
Your answer should be compact. 0.49. 